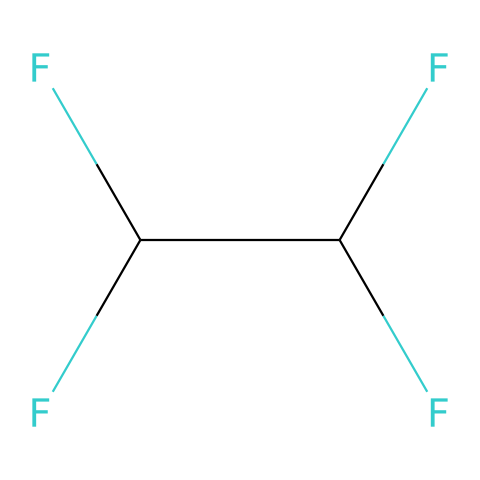What is the parent structure of this chemical? This chemical has a perfluorinated structure indicated by the presence of multiple fluorine atoms bonded to carbon. The presence of many fluorine groups suggests that the parent structure is related to a perfluorinated alkane.
Answer: perfluorinated alkane How many carbon atoms are in the structure? The SMILES notation shows that there are two carbon atoms (C) present in the chemical structure.
Answer: 2 What type of bonds are present in this chemical? The chemical structure indicates that there are single bonds between the carbon atoms and the fluorine atoms, as evidenced by the notation.
Answer: single bonds What properties would this chemical give to military uniforms? This chemical structure suggests weather resistance due to the fluorine atoms which impart hydrophobic properties, preventing water penetration while allowing vapor permeability.
Answer: weather resistance Why does the presence of fluorine influence the performance of fibers? The presence of fluorine creates a low-surface-energy surface that enhances water repellency, which is crucial for military uniforms in preventing moisture penetration while providing comfort.
Answer: water repellency 